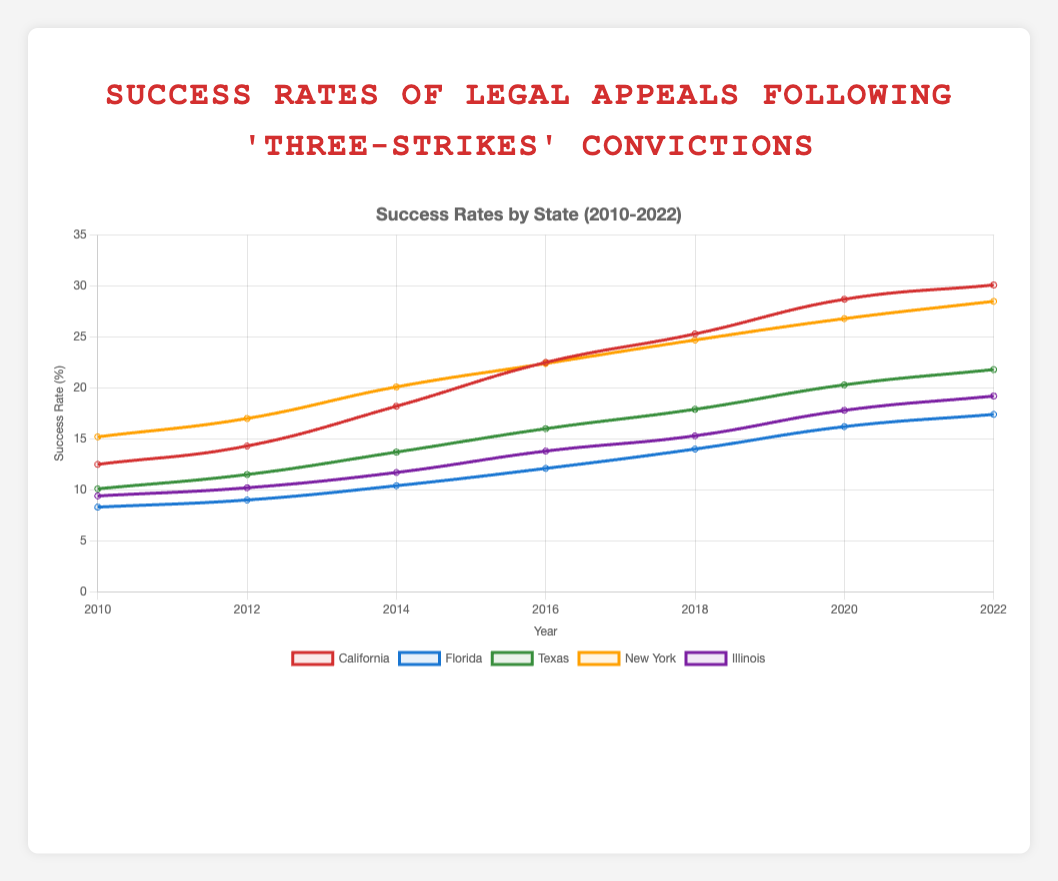What was the success rate of legal appeals in California in 2010? To find the success rate in California for 2010, look at the y-axis value for California in 2010.
Answer: 12.5% Which state had the highest success rate in 2014? Compare the success rates for all states in 2014; the highest rate is for New York.
Answer: New York How did the success rate for Texas change from 2010 to 2022? Calculate the difference between the success rate for Texas in 2022 and 2010. The rate increased from 10.1% to 21.8%.
Answer: 11.7 percentage points increase What is the average success rate for Florida over the period 2010-2022? Sum up the success rates for Florida over all years and then divide by the number of years: (8.3 + 9.0 + 10.4 + 12.1 + 14.0 + 16.2 + 17.4) / 7.
Answer: 12.06% Which states showed an increase in success rate every recorded year? Compare the success rates for each state at two-year intervals, noting if all rates show an increase. Only California, Texas, New York, and Illinois' rates consistently increased.
Answer: California, Texas, New York, Illinois Considering Texas and New York, which state had a sharper increase in success rates between 2012 and 2018? Calculate the difference between 2018 and 2012 for both states: Texas (17.9 - 11.5 = 6.4) and New York (24.7 - 17.0 = 7.7).
Answer: New York By how much did Illinois's success rate improve from 2016 to 2020? Subtract the 2016 rate from the 2020 rate for Illinois: 17.8 - 13.8.
Answer: 4 percentage points Which state had the lowest success rate in 2022? Compare the 2022 success rates for all states and identify the state with the minimum value.
Answer: Florida What is the overall trend for the success rates in California from 2010 to 2022? Observe the plot line for California over time. The success rate shows a consistently increasing trend.
Answer: Increasing Which state had a higher success rate in 2022: Texas or Illinois? Compare the success rates for Texas (21.8%) and Illinois (19.2%) in 2022.
Answer: Texas 